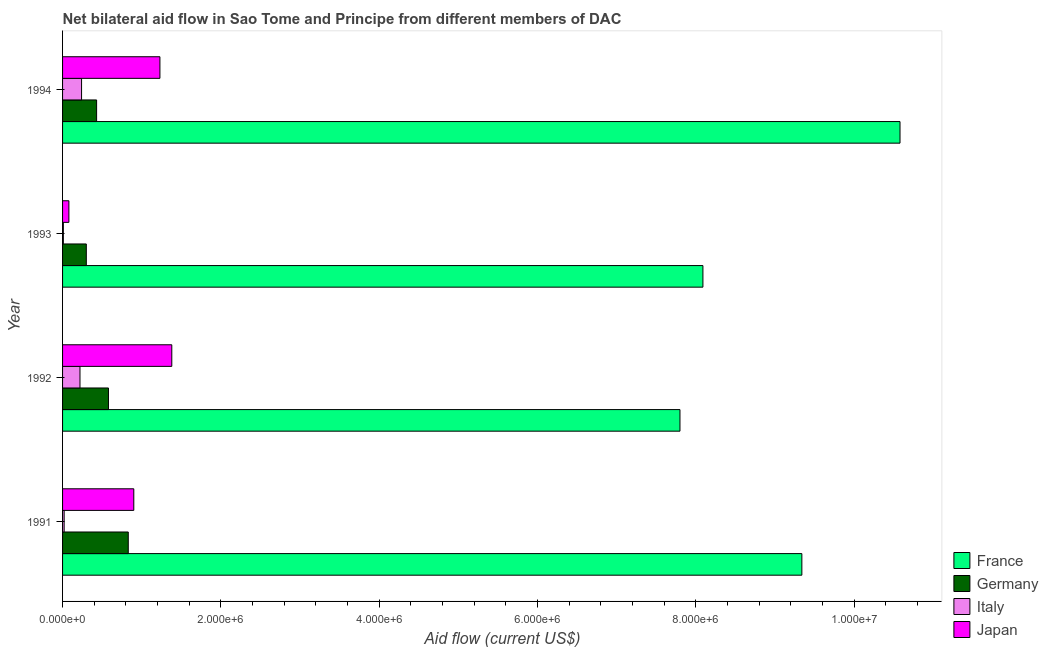How many different coloured bars are there?
Ensure brevity in your answer.  4. How many groups of bars are there?
Ensure brevity in your answer.  4. Are the number of bars per tick equal to the number of legend labels?
Ensure brevity in your answer.  Yes. How many bars are there on the 4th tick from the bottom?
Offer a terse response. 4. What is the amount of aid given by japan in 1992?
Make the answer very short. 1.38e+06. Across all years, what is the maximum amount of aid given by italy?
Your answer should be very brief. 2.40e+05. Across all years, what is the minimum amount of aid given by italy?
Your answer should be very brief. 10000. What is the total amount of aid given by germany in the graph?
Keep it short and to the point. 2.14e+06. What is the difference between the amount of aid given by italy in 1992 and that in 1993?
Offer a terse response. 2.10e+05. What is the difference between the amount of aid given by france in 1993 and the amount of aid given by japan in 1992?
Your response must be concise. 6.71e+06. What is the average amount of aid given by italy per year?
Keep it short and to the point. 1.22e+05. In the year 1991, what is the difference between the amount of aid given by italy and amount of aid given by japan?
Provide a short and direct response. -8.80e+05. What is the ratio of the amount of aid given by germany in 1991 to that in 1994?
Provide a succinct answer. 1.93. What is the difference between the highest and the second highest amount of aid given by germany?
Your response must be concise. 2.50e+05. What is the difference between the highest and the lowest amount of aid given by italy?
Give a very brief answer. 2.30e+05. Is the sum of the amount of aid given by france in 1991 and 1992 greater than the maximum amount of aid given by germany across all years?
Your answer should be very brief. Yes. What does the 3rd bar from the top in 1994 represents?
Provide a succinct answer. Germany. Is it the case that in every year, the sum of the amount of aid given by france and amount of aid given by germany is greater than the amount of aid given by italy?
Keep it short and to the point. Yes. How many bars are there?
Your answer should be very brief. 16. Are all the bars in the graph horizontal?
Your answer should be very brief. Yes. What is the difference between two consecutive major ticks on the X-axis?
Make the answer very short. 2.00e+06. How many legend labels are there?
Give a very brief answer. 4. What is the title of the graph?
Provide a succinct answer. Net bilateral aid flow in Sao Tome and Principe from different members of DAC. What is the Aid flow (current US$) of France in 1991?
Offer a terse response. 9.34e+06. What is the Aid flow (current US$) in Germany in 1991?
Offer a terse response. 8.30e+05. What is the Aid flow (current US$) of Italy in 1991?
Provide a short and direct response. 2.00e+04. What is the Aid flow (current US$) in Japan in 1991?
Your answer should be compact. 9.00e+05. What is the Aid flow (current US$) of France in 1992?
Keep it short and to the point. 7.80e+06. What is the Aid flow (current US$) of Germany in 1992?
Provide a short and direct response. 5.80e+05. What is the Aid flow (current US$) of Japan in 1992?
Make the answer very short. 1.38e+06. What is the Aid flow (current US$) of France in 1993?
Your answer should be very brief. 8.09e+06. What is the Aid flow (current US$) of Italy in 1993?
Offer a terse response. 10000. What is the Aid flow (current US$) of France in 1994?
Offer a very short reply. 1.06e+07. What is the Aid flow (current US$) of Italy in 1994?
Make the answer very short. 2.40e+05. What is the Aid flow (current US$) in Japan in 1994?
Provide a short and direct response. 1.23e+06. Across all years, what is the maximum Aid flow (current US$) in France?
Offer a very short reply. 1.06e+07. Across all years, what is the maximum Aid flow (current US$) in Germany?
Provide a succinct answer. 8.30e+05. Across all years, what is the maximum Aid flow (current US$) in Japan?
Offer a terse response. 1.38e+06. Across all years, what is the minimum Aid flow (current US$) of France?
Provide a short and direct response. 7.80e+06. Across all years, what is the minimum Aid flow (current US$) of Italy?
Provide a short and direct response. 10000. What is the total Aid flow (current US$) in France in the graph?
Provide a short and direct response. 3.58e+07. What is the total Aid flow (current US$) in Germany in the graph?
Make the answer very short. 2.14e+06. What is the total Aid flow (current US$) of Italy in the graph?
Offer a terse response. 4.90e+05. What is the total Aid flow (current US$) in Japan in the graph?
Ensure brevity in your answer.  3.59e+06. What is the difference between the Aid flow (current US$) in France in 1991 and that in 1992?
Provide a short and direct response. 1.54e+06. What is the difference between the Aid flow (current US$) of Italy in 1991 and that in 1992?
Your response must be concise. -2.00e+05. What is the difference between the Aid flow (current US$) in Japan in 1991 and that in 1992?
Provide a succinct answer. -4.80e+05. What is the difference between the Aid flow (current US$) in France in 1991 and that in 1993?
Provide a short and direct response. 1.25e+06. What is the difference between the Aid flow (current US$) in Germany in 1991 and that in 1993?
Make the answer very short. 5.30e+05. What is the difference between the Aid flow (current US$) of Japan in 1991 and that in 1993?
Make the answer very short. 8.20e+05. What is the difference between the Aid flow (current US$) of France in 1991 and that in 1994?
Your answer should be very brief. -1.24e+06. What is the difference between the Aid flow (current US$) in Germany in 1991 and that in 1994?
Your answer should be compact. 4.00e+05. What is the difference between the Aid flow (current US$) of Italy in 1991 and that in 1994?
Provide a short and direct response. -2.20e+05. What is the difference between the Aid flow (current US$) of Japan in 1991 and that in 1994?
Provide a short and direct response. -3.30e+05. What is the difference between the Aid flow (current US$) of Italy in 1992 and that in 1993?
Provide a succinct answer. 2.10e+05. What is the difference between the Aid flow (current US$) of Japan in 1992 and that in 1993?
Make the answer very short. 1.30e+06. What is the difference between the Aid flow (current US$) in France in 1992 and that in 1994?
Your response must be concise. -2.78e+06. What is the difference between the Aid flow (current US$) in France in 1993 and that in 1994?
Keep it short and to the point. -2.49e+06. What is the difference between the Aid flow (current US$) of Japan in 1993 and that in 1994?
Keep it short and to the point. -1.15e+06. What is the difference between the Aid flow (current US$) in France in 1991 and the Aid flow (current US$) in Germany in 1992?
Provide a short and direct response. 8.76e+06. What is the difference between the Aid flow (current US$) of France in 1991 and the Aid flow (current US$) of Italy in 1992?
Offer a very short reply. 9.12e+06. What is the difference between the Aid flow (current US$) of France in 1991 and the Aid flow (current US$) of Japan in 1992?
Offer a very short reply. 7.96e+06. What is the difference between the Aid flow (current US$) in Germany in 1991 and the Aid flow (current US$) in Japan in 1992?
Ensure brevity in your answer.  -5.50e+05. What is the difference between the Aid flow (current US$) in Italy in 1991 and the Aid flow (current US$) in Japan in 1992?
Keep it short and to the point. -1.36e+06. What is the difference between the Aid flow (current US$) in France in 1991 and the Aid flow (current US$) in Germany in 1993?
Offer a very short reply. 9.04e+06. What is the difference between the Aid flow (current US$) of France in 1991 and the Aid flow (current US$) of Italy in 1993?
Make the answer very short. 9.33e+06. What is the difference between the Aid flow (current US$) in France in 1991 and the Aid flow (current US$) in Japan in 1993?
Your response must be concise. 9.26e+06. What is the difference between the Aid flow (current US$) of Germany in 1991 and the Aid flow (current US$) of Italy in 1993?
Ensure brevity in your answer.  8.20e+05. What is the difference between the Aid flow (current US$) in Germany in 1991 and the Aid flow (current US$) in Japan in 1993?
Ensure brevity in your answer.  7.50e+05. What is the difference between the Aid flow (current US$) of Italy in 1991 and the Aid flow (current US$) of Japan in 1993?
Provide a succinct answer. -6.00e+04. What is the difference between the Aid flow (current US$) in France in 1991 and the Aid flow (current US$) in Germany in 1994?
Your answer should be very brief. 8.91e+06. What is the difference between the Aid flow (current US$) in France in 1991 and the Aid flow (current US$) in Italy in 1994?
Your response must be concise. 9.10e+06. What is the difference between the Aid flow (current US$) in France in 1991 and the Aid flow (current US$) in Japan in 1994?
Your answer should be very brief. 8.11e+06. What is the difference between the Aid flow (current US$) in Germany in 1991 and the Aid flow (current US$) in Italy in 1994?
Your answer should be compact. 5.90e+05. What is the difference between the Aid flow (current US$) of Germany in 1991 and the Aid flow (current US$) of Japan in 1994?
Provide a succinct answer. -4.00e+05. What is the difference between the Aid flow (current US$) in Italy in 1991 and the Aid flow (current US$) in Japan in 1994?
Your response must be concise. -1.21e+06. What is the difference between the Aid flow (current US$) of France in 1992 and the Aid flow (current US$) of Germany in 1993?
Ensure brevity in your answer.  7.50e+06. What is the difference between the Aid flow (current US$) of France in 1992 and the Aid flow (current US$) of Italy in 1993?
Offer a terse response. 7.79e+06. What is the difference between the Aid flow (current US$) in France in 1992 and the Aid flow (current US$) in Japan in 1993?
Offer a very short reply. 7.72e+06. What is the difference between the Aid flow (current US$) in Germany in 1992 and the Aid flow (current US$) in Italy in 1993?
Give a very brief answer. 5.70e+05. What is the difference between the Aid flow (current US$) in Germany in 1992 and the Aid flow (current US$) in Japan in 1993?
Offer a terse response. 5.00e+05. What is the difference between the Aid flow (current US$) of France in 1992 and the Aid flow (current US$) of Germany in 1994?
Your answer should be compact. 7.37e+06. What is the difference between the Aid flow (current US$) in France in 1992 and the Aid flow (current US$) in Italy in 1994?
Your answer should be compact. 7.56e+06. What is the difference between the Aid flow (current US$) in France in 1992 and the Aid flow (current US$) in Japan in 1994?
Ensure brevity in your answer.  6.57e+06. What is the difference between the Aid flow (current US$) in Germany in 1992 and the Aid flow (current US$) in Japan in 1994?
Offer a very short reply. -6.50e+05. What is the difference between the Aid flow (current US$) of Italy in 1992 and the Aid flow (current US$) of Japan in 1994?
Offer a terse response. -1.01e+06. What is the difference between the Aid flow (current US$) of France in 1993 and the Aid flow (current US$) of Germany in 1994?
Your answer should be compact. 7.66e+06. What is the difference between the Aid flow (current US$) of France in 1993 and the Aid flow (current US$) of Italy in 1994?
Give a very brief answer. 7.85e+06. What is the difference between the Aid flow (current US$) of France in 1993 and the Aid flow (current US$) of Japan in 1994?
Your response must be concise. 6.86e+06. What is the difference between the Aid flow (current US$) in Germany in 1993 and the Aid flow (current US$) in Italy in 1994?
Your answer should be compact. 6.00e+04. What is the difference between the Aid flow (current US$) of Germany in 1993 and the Aid flow (current US$) of Japan in 1994?
Offer a very short reply. -9.30e+05. What is the difference between the Aid flow (current US$) in Italy in 1993 and the Aid flow (current US$) in Japan in 1994?
Give a very brief answer. -1.22e+06. What is the average Aid flow (current US$) in France per year?
Offer a very short reply. 8.95e+06. What is the average Aid flow (current US$) in Germany per year?
Your response must be concise. 5.35e+05. What is the average Aid flow (current US$) in Italy per year?
Offer a very short reply. 1.22e+05. What is the average Aid flow (current US$) in Japan per year?
Your answer should be compact. 8.98e+05. In the year 1991, what is the difference between the Aid flow (current US$) in France and Aid flow (current US$) in Germany?
Keep it short and to the point. 8.51e+06. In the year 1991, what is the difference between the Aid flow (current US$) of France and Aid flow (current US$) of Italy?
Offer a very short reply. 9.32e+06. In the year 1991, what is the difference between the Aid flow (current US$) in France and Aid flow (current US$) in Japan?
Provide a succinct answer. 8.44e+06. In the year 1991, what is the difference between the Aid flow (current US$) of Germany and Aid flow (current US$) of Italy?
Provide a short and direct response. 8.10e+05. In the year 1991, what is the difference between the Aid flow (current US$) in Germany and Aid flow (current US$) in Japan?
Your response must be concise. -7.00e+04. In the year 1991, what is the difference between the Aid flow (current US$) of Italy and Aid flow (current US$) of Japan?
Your response must be concise. -8.80e+05. In the year 1992, what is the difference between the Aid flow (current US$) in France and Aid flow (current US$) in Germany?
Provide a succinct answer. 7.22e+06. In the year 1992, what is the difference between the Aid flow (current US$) in France and Aid flow (current US$) in Italy?
Offer a very short reply. 7.58e+06. In the year 1992, what is the difference between the Aid flow (current US$) in France and Aid flow (current US$) in Japan?
Provide a short and direct response. 6.42e+06. In the year 1992, what is the difference between the Aid flow (current US$) of Germany and Aid flow (current US$) of Japan?
Ensure brevity in your answer.  -8.00e+05. In the year 1992, what is the difference between the Aid flow (current US$) in Italy and Aid flow (current US$) in Japan?
Your response must be concise. -1.16e+06. In the year 1993, what is the difference between the Aid flow (current US$) of France and Aid flow (current US$) of Germany?
Provide a short and direct response. 7.79e+06. In the year 1993, what is the difference between the Aid flow (current US$) in France and Aid flow (current US$) in Italy?
Ensure brevity in your answer.  8.08e+06. In the year 1993, what is the difference between the Aid flow (current US$) in France and Aid flow (current US$) in Japan?
Your answer should be compact. 8.01e+06. In the year 1994, what is the difference between the Aid flow (current US$) of France and Aid flow (current US$) of Germany?
Provide a succinct answer. 1.02e+07. In the year 1994, what is the difference between the Aid flow (current US$) of France and Aid flow (current US$) of Italy?
Make the answer very short. 1.03e+07. In the year 1994, what is the difference between the Aid flow (current US$) in France and Aid flow (current US$) in Japan?
Keep it short and to the point. 9.35e+06. In the year 1994, what is the difference between the Aid flow (current US$) in Germany and Aid flow (current US$) in Italy?
Give a very brief answer. 1.90e+05. In the year 1994, what is the difference between the Aid flow (current US$) in Germany and Aid flow (current US$) in Japan?
Provide a succinct answer. -8.00e+05. In the year 1994, what is the difference between the Aid flow (current US$) of Italy and Aid flow (current US$) of Japan?
Your answer should be compact. -9.90e+05. What is the ratio of the Aid flow (current US$) in France in 1991 to that in 1992?
Offer a terse response. 1.2. What is the ratio of the Aid flow (current US$) in Germany in 1991 to that in 1992?
Provide a short and direct response. 1.43. What is the ratio of the Aid flow (current US$) in Italy in 1991 to that in 1992?
Your answer should be very brief. 0.09. What is the ratio of the Aid flow (current US$) of Japan in 1991 to that in 1992?
Offer a terse response. 0.65. What is the ratio of the Aid flow (current US$) in France in 1991 to that in 1993?
Offer a terse response. 1.15. What is the ratio of the Aid flow (current US$) in Germany in 1991 to that in 1993?
Offer a very short reply. 2.77. What is the ratio of the Aid flow (current US$) in Japan in 1991 to that in 1993?
Ensure brevity in your answer.  11.25. What is the ratio of the Aid flow (current US$) of France in 1991 to that in 1994?
Keep it short and to the point. 0.88. What is the ratio of the Aid flow (current US$) in Germany in 1991 to that in 1994?
Your answer should be very brief. 1.93. What is the ratio of the Aid flow (current US$) of Italy in 1991 to that in 1994?
Your response must be concise. 0.08. What is the ratio of the Aid flow (current US$) of Japan in 1991 to that in 1994?
Ensure brevity in your answer.  0.73. What is the ratio of the Aid flow (current US$) in France in 1992 to that in 1993?
Offer a terse response. 0.96. What is the ratio of the Aid flow (current US$) in Germany in 1992 to that in 1993?
Give a very brief answer. 1.93. What is the ratio of the Aid flow (current US$) of Japan in 1992 to that in 1993?
Provide a succinct answer. 17.25. What is the ratio of the Aid flow (current US$) in France in 1992 to that in 1994?
Keep it short and to the point. 0.74. What is the ratio of the Aid flow (current US$) in Germany in 1992 to that in 1994?
Ensure brevity in your answer.  1.35. What is the ratio of the Aid flow (current US$) of Japan in 1992 to that in 1994?
Offer a very short reply. 1.12. What is the ratio of the Aid flow (current US$) in France in 1993 to that in 1994?
Your response must be concise. 0.76. What is the ratio of the Aid flow (current US$) in Germany in 1993 to that in 1994?
Provide a short and direct response. 0.7. What is the ratio of the Aid flow (current US$) of Italy in 1993 to that in 1994?
Give a very brief answer. 0.04. What is the ratio of the Aid flow (current US$) of Japan in 1993 to that in 1994?
Your answer should be compact. 0.07. What is the difference between the highest and the second highest Aid flow (current US$) of France?
Your response must be concise. 1.24e+06. What is the difference between the highest and the second highest Aid flow (current US$) in Germany?
Make the answer very short. 2.50e+05. What is the difference between the highest and the lowest Aid flow (current US$) of France?
Your answer should be compact. 2.78e+06. What is the difference between the highest and the lowest Aid flow (current US$) in Germany?
Offer a very short reply. 5.30e+05. What is the difference between the highest and the lowest Aid flow (current US$) in Japan?
Offer a very short reply. 1.30e+06. 